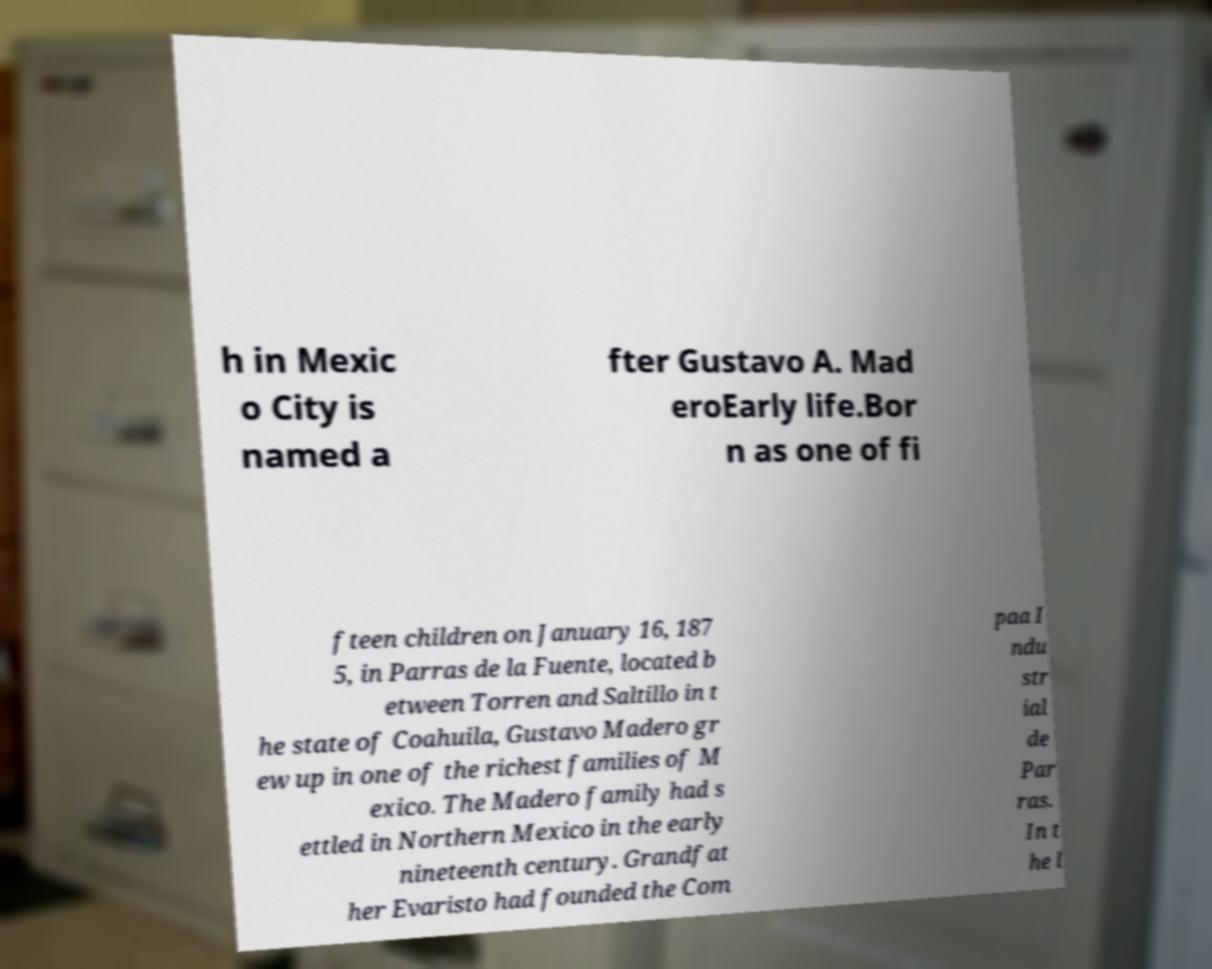Can you accurately transcribe the text from the provided image for me? h in Mexic o City is named a fter Gustavo A. Mad eroEarly life.Bor n as one of fi fteen children on January 16, 187 5, in Parras de la Fuente, located b etween Torren and Saltillo in t he state of Coahuila, Gustavo Madero gr ew up in one of the richest families of M exico. The Madero family had s ettled in Northern Mexico in the early nineteenth century. Grandfat her Evaristo had founded the Com paa I ndu str ial de Par ras. In t he l 